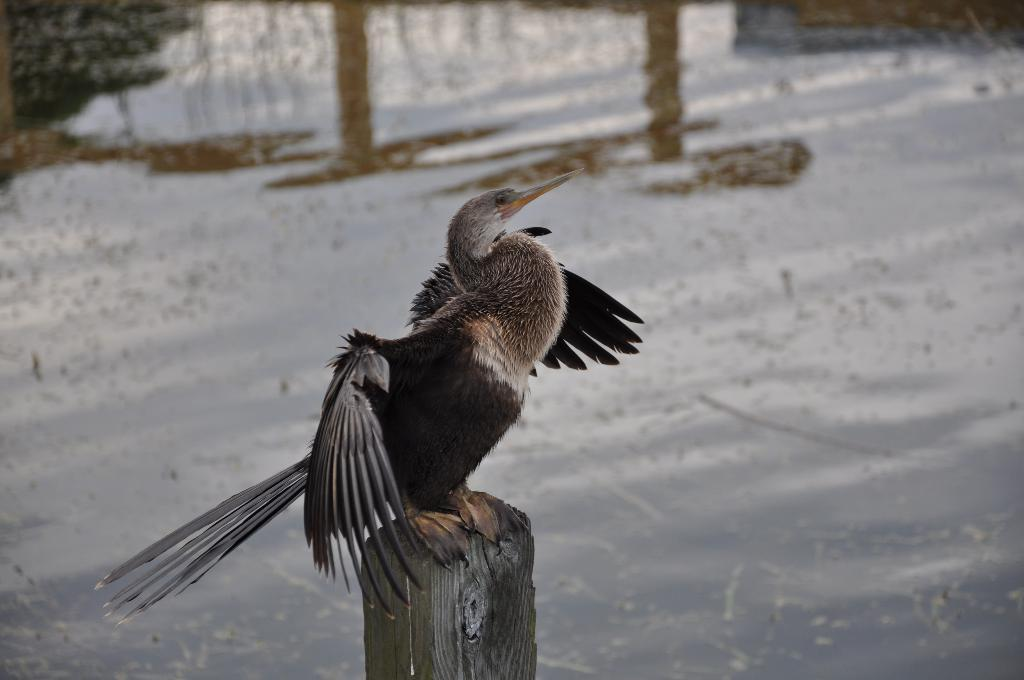What is the main subject in the center of the image? There is a bird in the center of the image. What is the bird standing on? The bird is on wood. What can be seen in the background of the image? There is water visible in the background of the image. What type of rhythm is the bird creating on the desk in the image? There is no desk present in the image, and the bird is not creating any rhythm. 